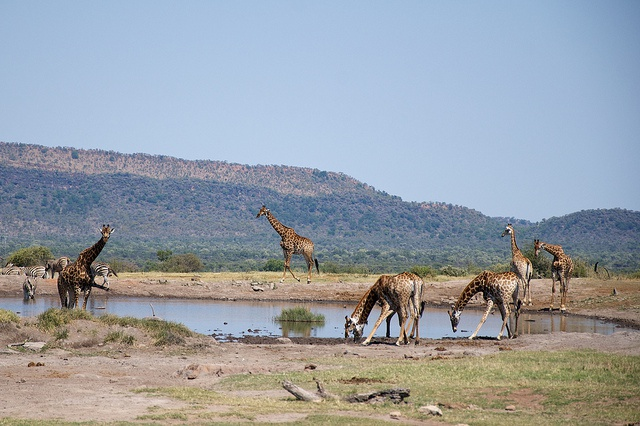Describe the objects in this image and their specific colors. I can see giraffe in lightblue, black, gray, and tan tones, giraffe in lightblue, black, gray, and tan tones, giraffe in lightblue, black, maroon, and gray tones, giraffe in lightblue, gray, tan, and black tones, and giraffe in lightblue, gray, tan, and darkgray tones in this image. 